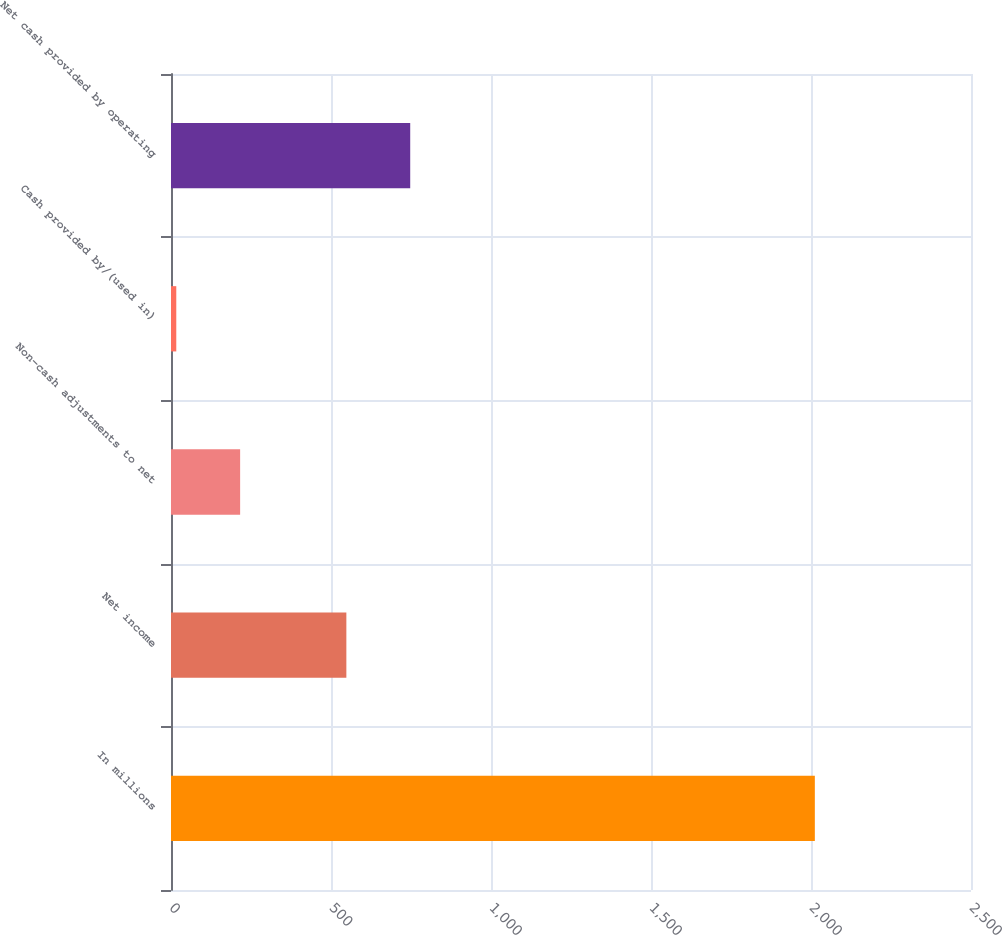Convert chart. <chart><loc_0><loc_0><loc_500><loc_500><bar_chart><fcel>In millions<fcel>Net income<fcel>Non-cash adjustments to net<fcel>Cash provided by/(used in)<fcel>Net cash provided by operating<nl><fcel>2012<fcel>548<fcel>216.05<fcel>16.5<fcel>747.55<nl></chart> 